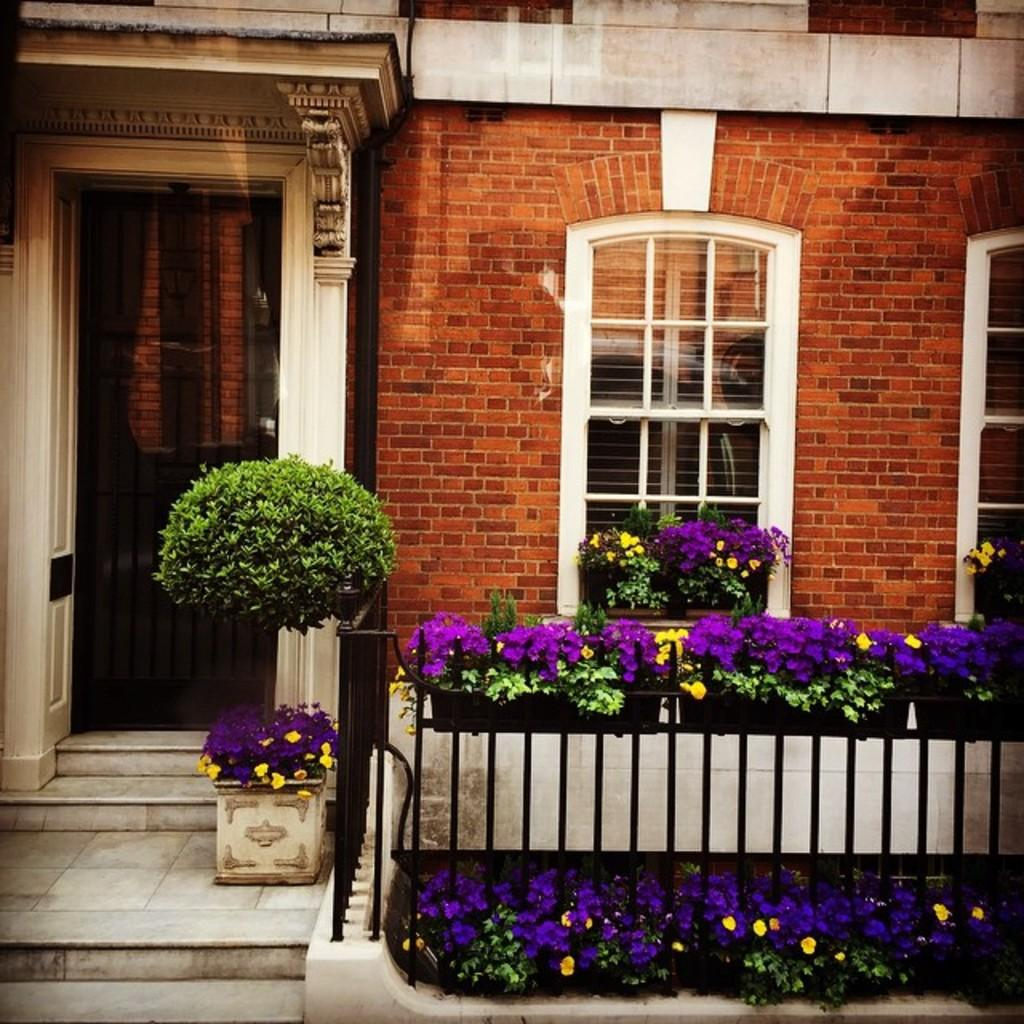What type of structure is present in the image? There is a building in the image. What features can be observed on the building? The building has windows and railing. What type of vegetation is present in the image? There are plants with flowers in the image. Can you see anyone kicking a grape in the image? There is no grape or kicking action present in the image. 